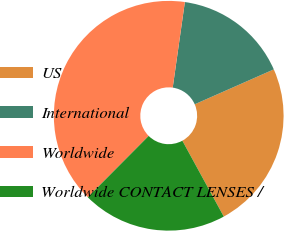<chart> <loc_0><loc_0><loc_500><loc_500><pie_chart><fcel>US<fcel>International<fcel>Worldwide<fcel>Worldwide CONTACT LENSES /<nl><fcel>23.66%<fcel>16.14%<fcel>39.8%<fcel>20.4%<nl></chart> 